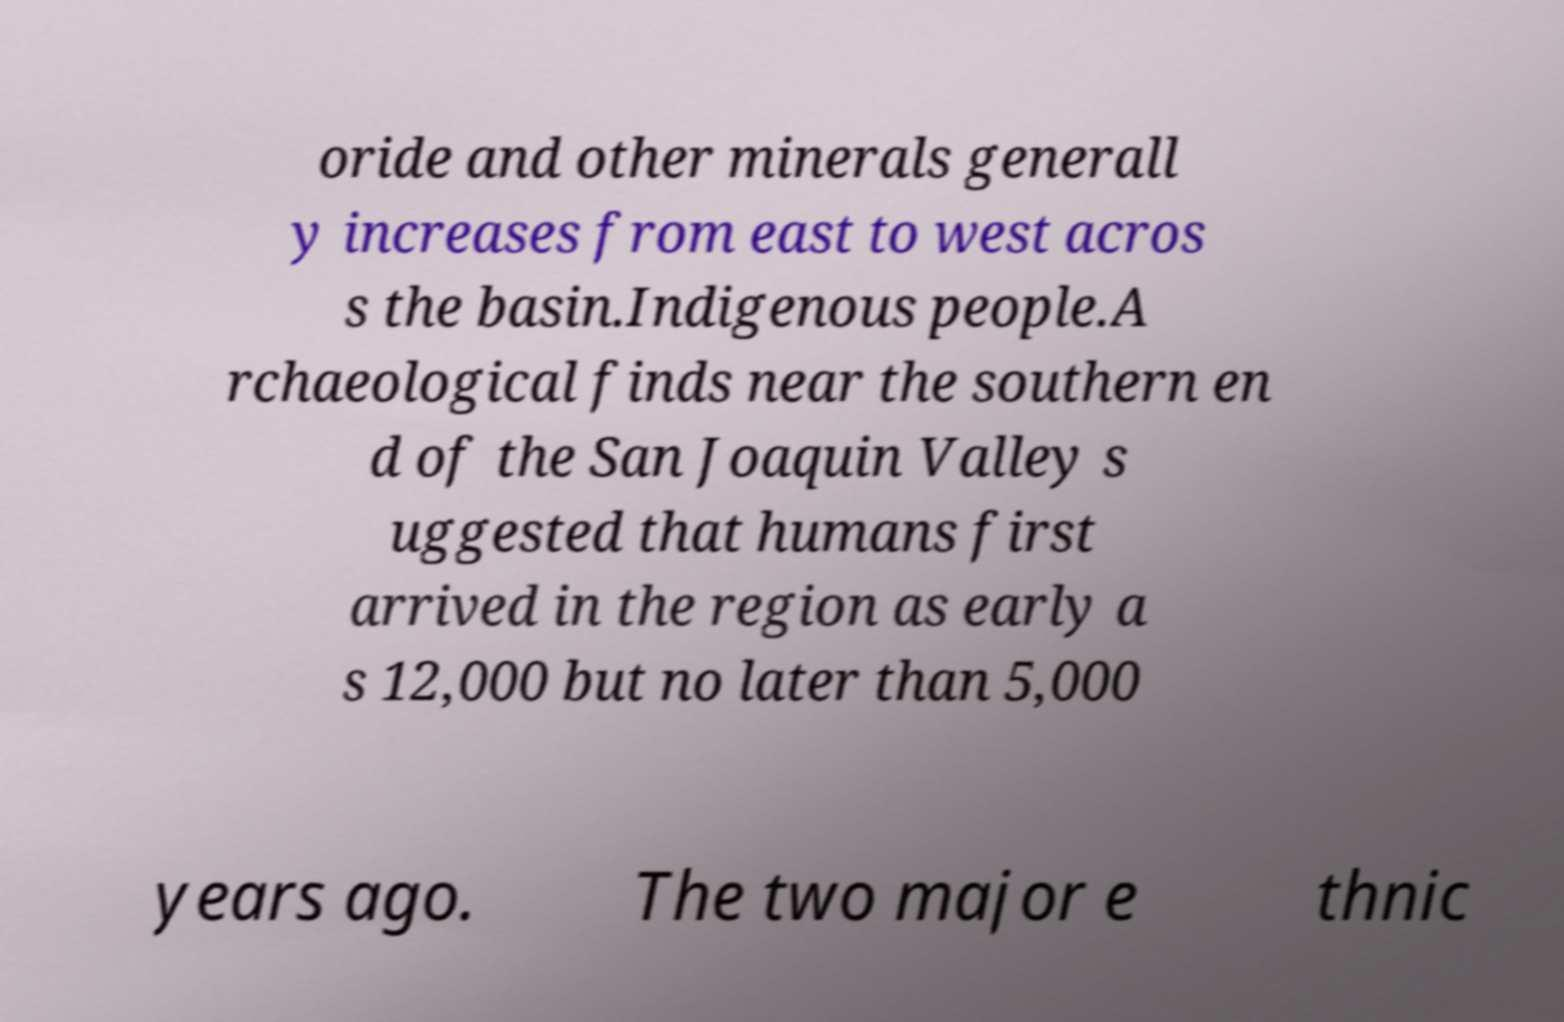Please identify and transcribe the text found in this image. oride and other minerals generall y increases from east to west acros s the basin.Indigenous people.A rchaeological finds near the southern en d of the San Joaquin Valley s uggested that humans first arrived in the region as early a s 12,000 but no later than 5,000 years ago. The two major e thnic 